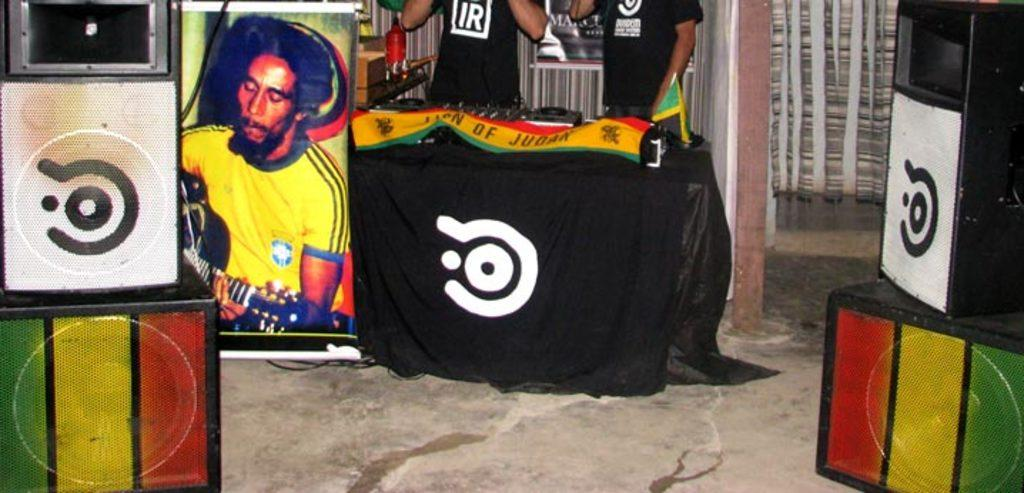How many people are in the image? There are two persons in the image. What is present in the image besides the people? There is a table, a cloth on the table, a banner on the table, and speakers in the image. What color is the hydrant in the image? There is no hydrant present in the image. What level of difficulty is the game being played in the image? There is no game present in the image, so it is not possible to determine the level of difficulty. 